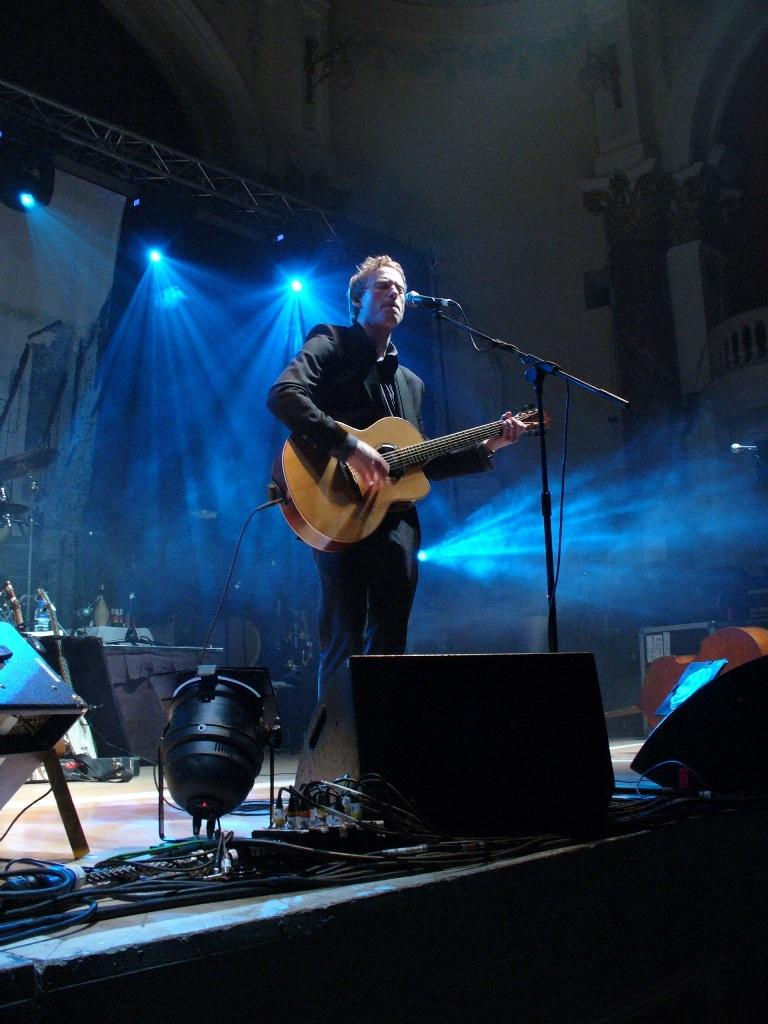What can be seen at the top of the image? There are lights visible at the top of the image. What is the man in the image doing? The man is standing on a platform and playing a guitar. What object is the man using to amplify his voice? The man is in front of a microphone. What type of kite is the man flying in the image? There is no kite present in the image; the man is playing a guitar and standing in front of a microphone. 